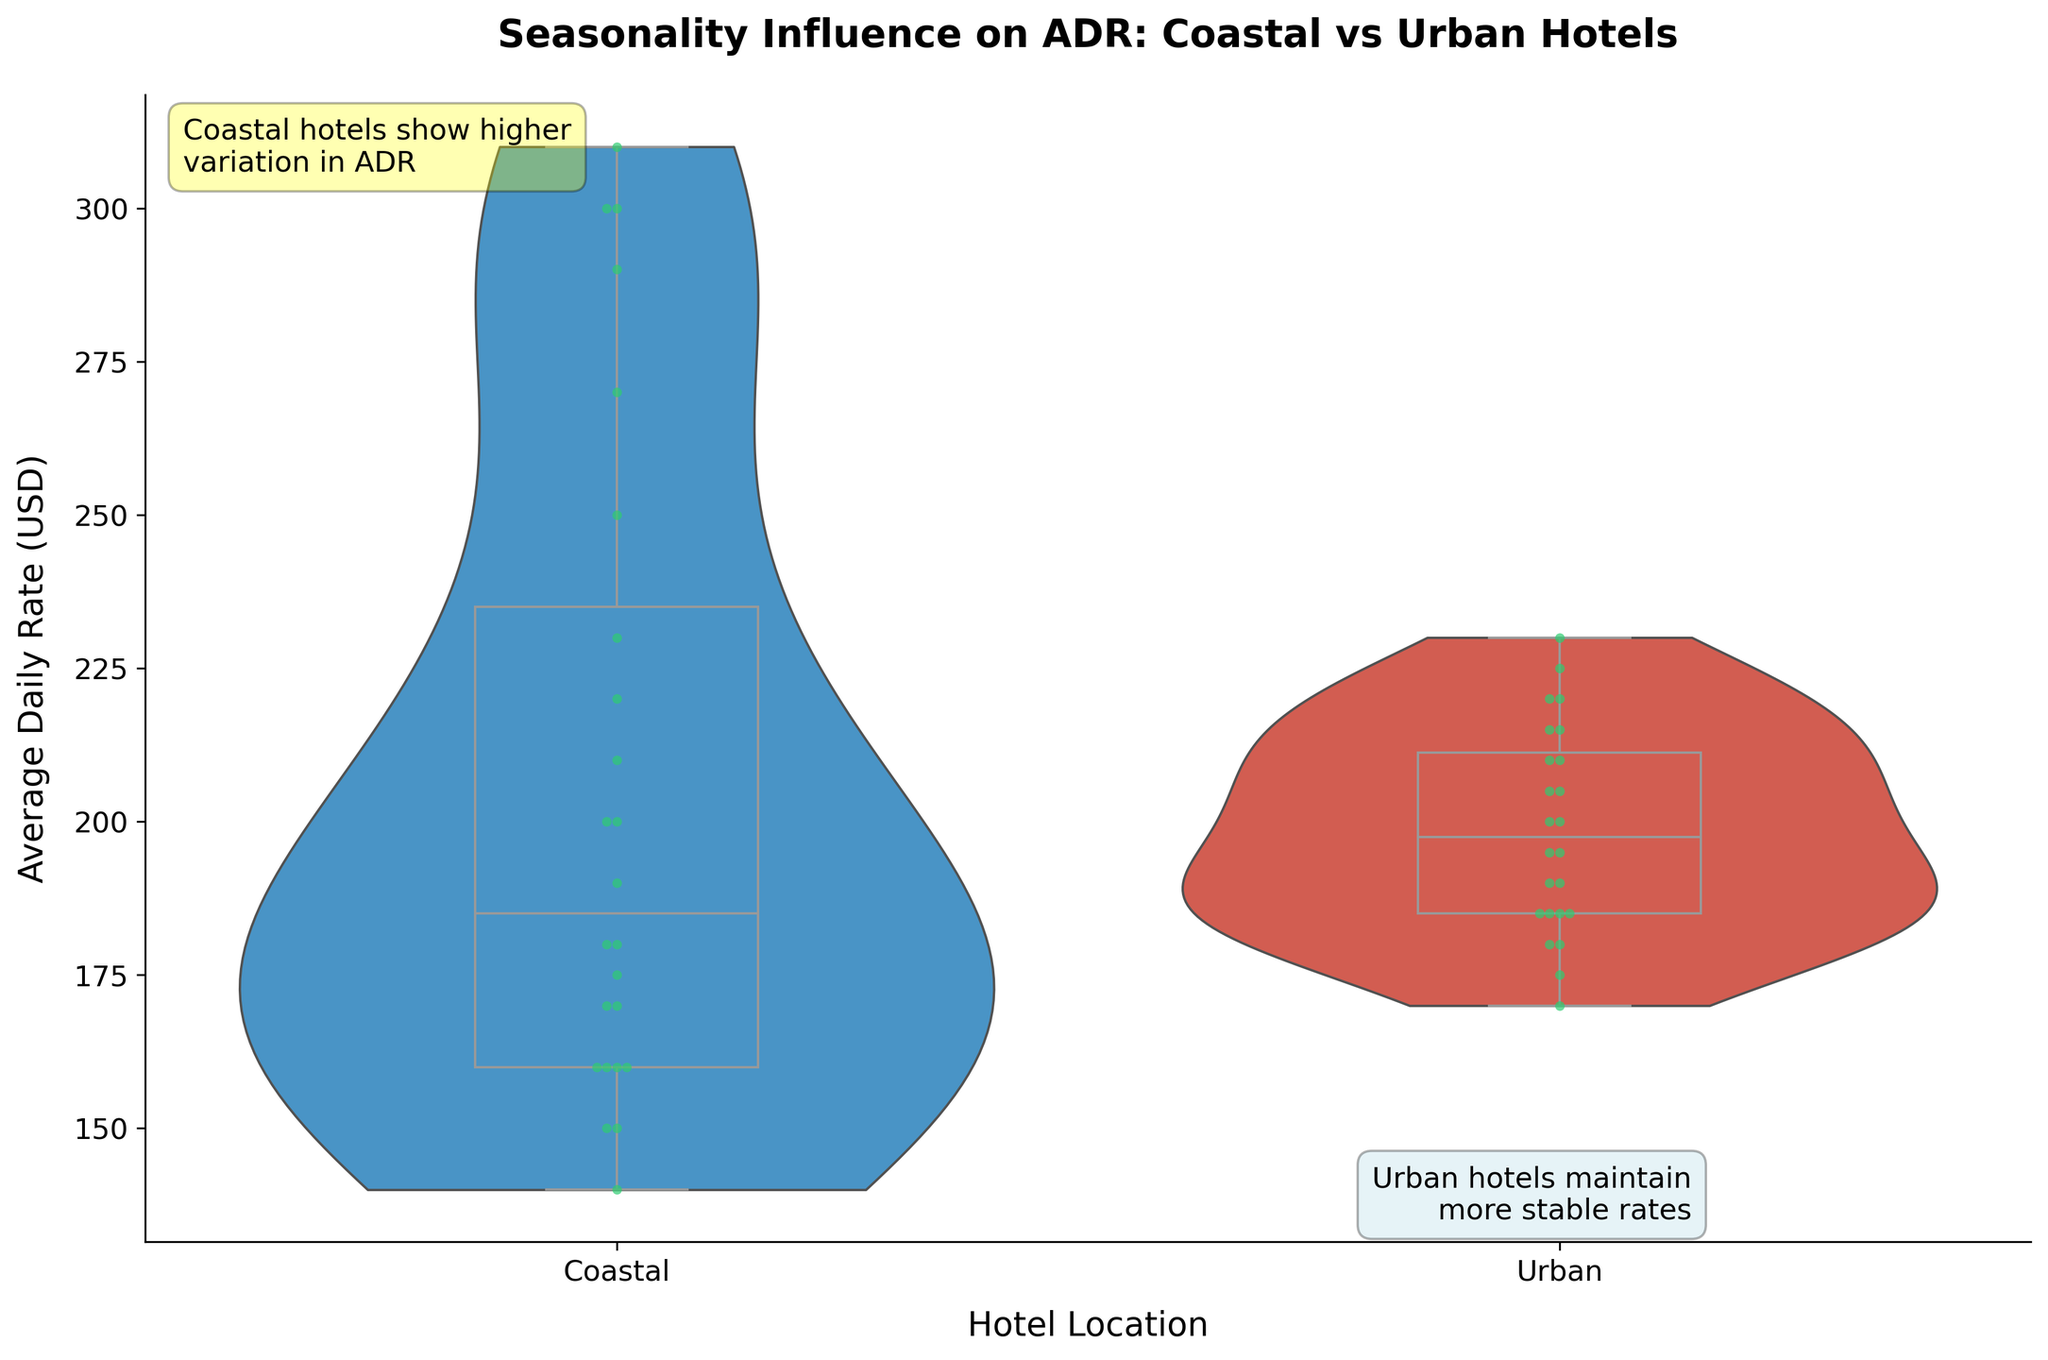What is the title of the figure? The title of the figure is usually located at the top of the plot. In this case, the title reads, "Seasonality Influence on ADR: Coastal vs Urban Hotels".
Answer: Seasonality Influence on ADR: Coastal vs Urban Hotels What do the different colors signify in the figure? In the figure, different colors signify different hotel locations: Coastal hotels are represented in blue, while Urban hotels are shown in red. Green dots represent individual data points in both locations.
Answer: Blue represents Coastal hotels; Red represents Urban hotels What is the median ADR for Coastal hotels? The median ADR for Coastal hotels can be identified from the box plot overlay on the blue violin plot. The median is indicated by the line inside the box, around $220.
Answer: $220 How does the variability in ADR compare between Coastal and Urban hotels? To compare variability, we look at the spread of the violin plots and the interquartile range of the box plots. Coastal hotels show a wider spread and larger interquartile range, indicating higher variability.
Answer: Coastal hotels have higher variability Which location shows more extreme outliers in ADR? Extreme outliers can be spotted by examining the individual data points (green dots) beyond the range of the box plots. Coastal hotels have several points noticeably higher, indicating more extreme ADR outliers.
Answer: Coastal hotels What is the range of ADR for Urban hotels? The range can be determined by looking at the highest and lowest points on the red violin plot for Urban hotels. ADR ranges approximately from $170 to $230.
Answer: $170 to $230 In which month do Coastal hotels have the highest ADR? Observing the figure, the distribution peak for Coastal hotels in the violin plot is highest in the summer months, particularly July and August, suggesting these months have the highest ADR.
Answer: July and August Which location has a more stable ADR throughout the year and why? Stability can be inferred from the width of the violin plots. Urban hotels have a narrower violin plot with less spread, indicating more stable ADR.
Answer: Urban hotels are more stable What is the difference between the peak ADRs of Coastal and Urban hotels? Find the peak ADR values for both locations from their violin plots. Coastal hotels peak around $310, while Urban hotels peak around $230. The difference is $310 - $230 = $80.
Answer: $80 Which hotel location is highlighted as maintaining more stable rates? Text annotations in the figure point out stability in ADR for Urban hotels, emphasizing their consistency.
Answer: Urban hotels 